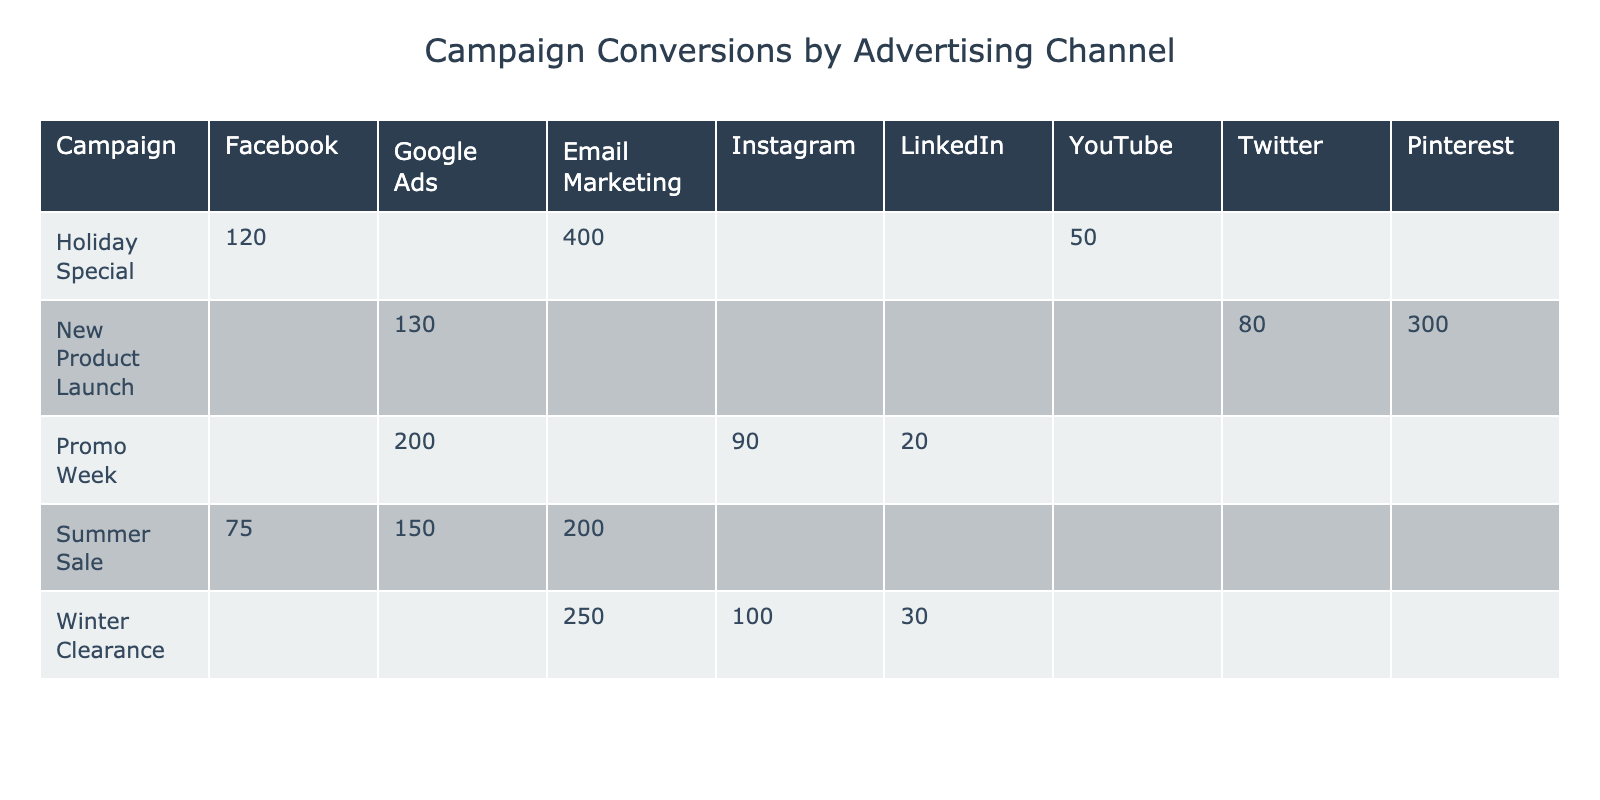What's the total number of conversions for the "Holiday Special" campaign? In the table, the conversions for "Holiday Special" are 50 (Pinterest), 400 (Google Ads), and 120 (Email Marketing). Adding these gives us 50 + 400 + 120 = 570.
Answer: 570 Which advertising channel had the highest number of conversions in the "New Product Launch" campaign? The "New Product Launch" campaign has the following conversions: 300 (YouTube), 80 (Twitter), and 130 (Facebook). The highest value is 300 from YouTube.
Answer: YouTube What are the conversions for the "Winter Clearance" campaign on Google Ads? In the table, for the "Winter Clearance" campaign, the conversions for Google Ads are listed as 250.
Answer: 250 Which campaign had the lowest conversions and what was the channel? Looking at the table, the campaign with the lowest conversions is "Winter Clearance" on LinkedIn, which had 30 conversions.
Answer: Winter Clearance, LinkedIn What percentage of conversions did the "Promo Week" campaign achieve from Facebook? For "Promo Week," the conversions from Facebook are 200 out of a total of 200 (Facebook) + 90 (Instagram) + 20 (LinkedIn) = 310. To find the percentage, we calculate (200/310) * 100 which is approximately 64.52%.
Answer: Approximately 64.52% Which channel across all campaigns appears to be consistently effective with high conversions? By reviewing the table, Google Ads shows a strong performance in multiple campaigns with high conversions (200, 250, 400).
Answer: Google Ads If the total cost for the "New Product Launch" campaign is divided by total conversions, what is the cost per conversion? The total conversions for "New Product Launch" are 300 (YouTube) + 80 (Twitter) + 130 (Facebook) = 510. The total cost is 800 (YouTube) + 200 (Twitter) + 250 (Facebook) = 1250. Thus, cost per conversion is 1250 / 510 ≈ 2.45.
Answer: Approximately 2.45 Which campaign had the highest total cost, and what was the amount? By examining the costs associated with each campaign, "Holiday Special" has the highest total cost of 900 (Google Ads) which is the largest single cost and sums to more than others.
Answer: 900 What is the average number of conversions for all campaigns on Instagram? The conversions on Instagram are 90 (Promo Week) and 100 (Winter Clearance). The average is calculated as (90 + 100) / 2 = 95.
Answer: 95 True or False: The "Summer Sale" campaign achieved more conversions on Email Marketing than on Facebook. In the "Summer Sale" campaign, there are 75 conversions for Email Marketing and 150 for Facebook. Since 75 is less than 150, the statement is False.
Answer: False How many conversions do the campaigns "Promo Week" and "Holiday Special" achieve combined from Facebook? "Promo Week" has 200 conversions from Facebook and "Holiday Special" has 130 conversions from Facebook. Together, the combined conversions are 200 + 130 = 330.
Answer: 330 